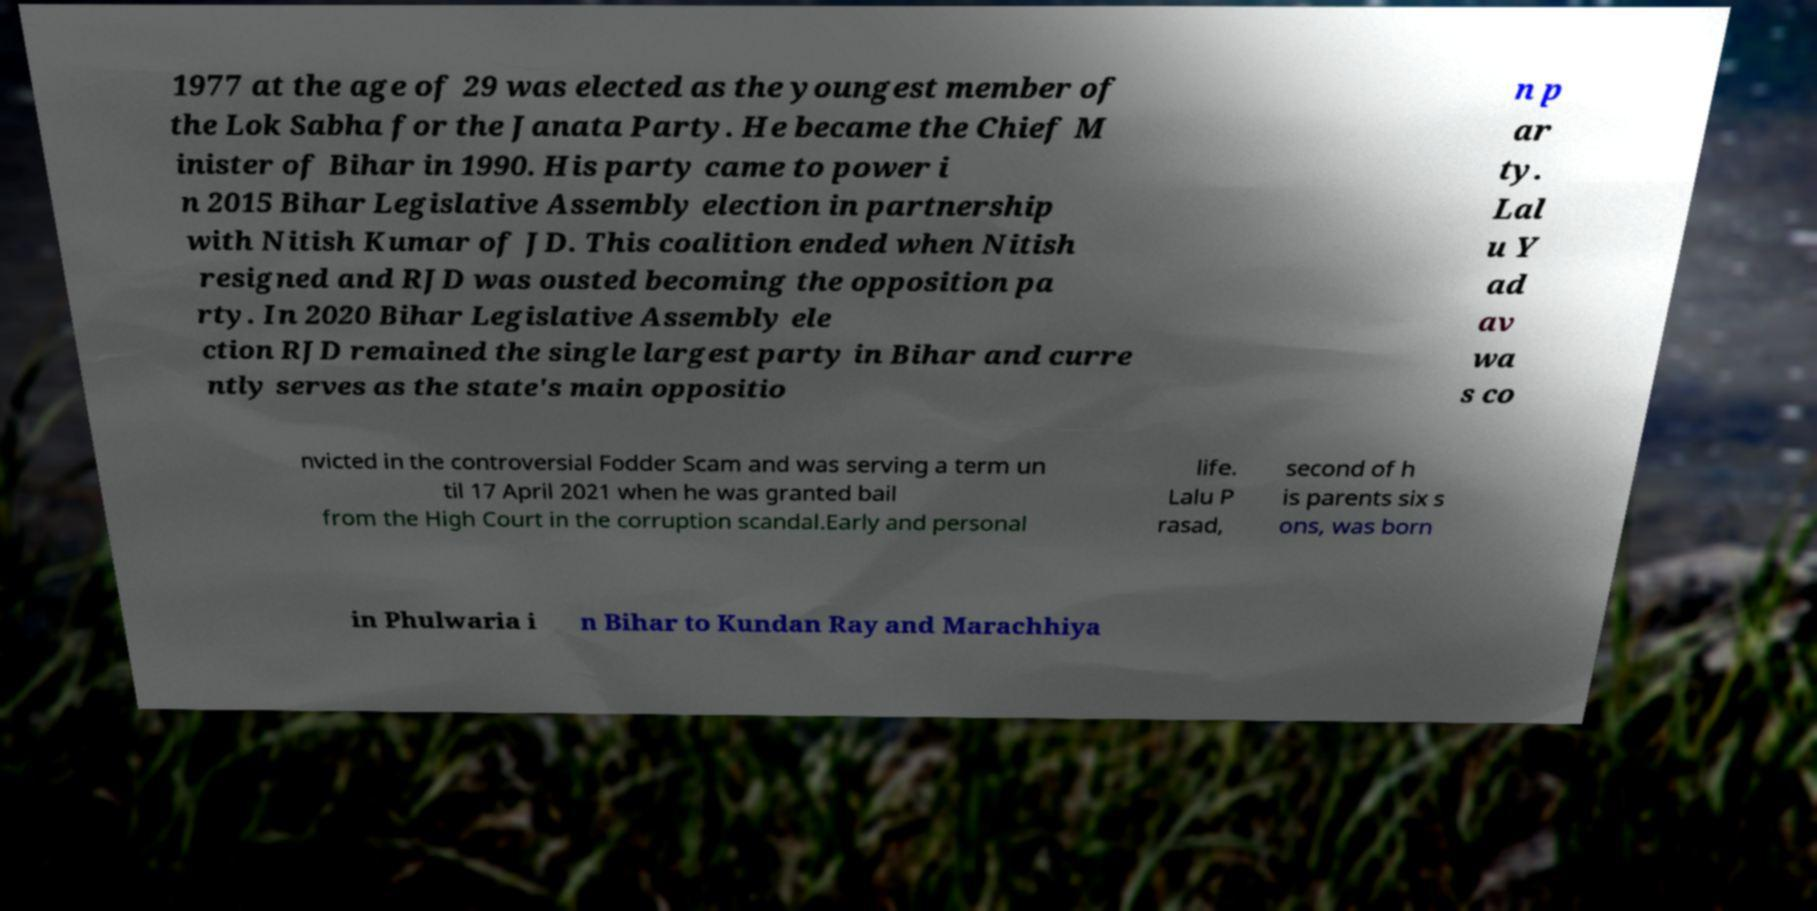I need the written content from this picture converted into text. Can you do that? 1977 at the age of 29 was elected as the youngest member of the Lok Sabha for the Janata Party. He became the Chief M inister of Bihar in 1990. His party came to power i n 2015 Bihar Legislative Assembly election in partnership with Nitish Kumar of JD. This coalition ended when Nitish resigned and RJD was ousted becoming the opposition pa rty. In 2020 Bihar Legislative Assembly ele ction RJD remained the single largest party in Bihar and curre ntly serves as the state's main oppositio n p ar ty. Lal u Y ad av wa s co nvicted in the controversial Fodder Scam and was serving a term un til 17 April 2021 when he was granted bail from the High Court in the corruption scandal.Early and personal life. Lalu P rasad, second of h is parents six s ons, was born in Phulwaria i n Bihar to Kundan Ray and Marachhiya 